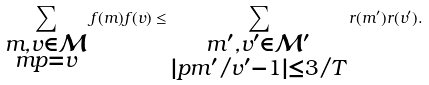Convert formula to latex. <formula><loc_0><loc_0><loc_500><loc_500>\sum _ { \substack { m , v \in \mathcal { M } \\ m p = v } } f ( m ) f ( v ) \leq \sum _ { \substack { m ^ { \prime } , v ^ { \prime } \in \mathcal { M } ^ { \prime } \\ | p m ^ { \prime } / v ^ { \prime } - 1 | \leq 3 / T } } r ( m ^ { \prime } ) r ( v ^ { \prime } ) .</formula> 